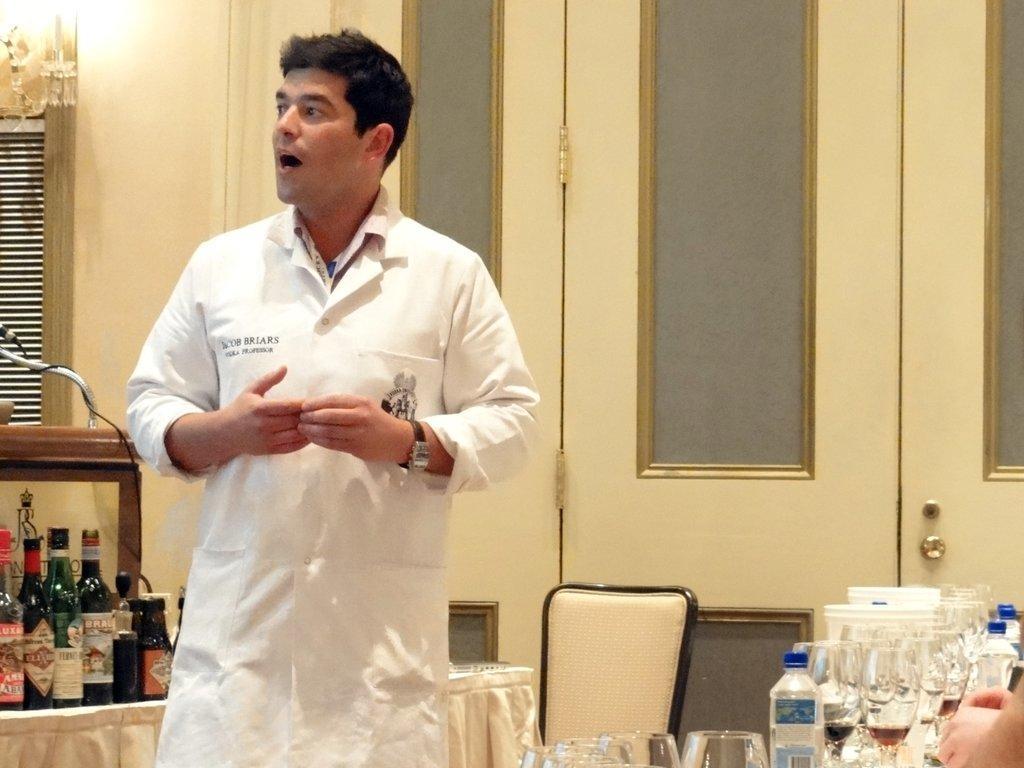Can you describe this image briefly? In this image there is a person wearing a white shirt is standing before a table having few bottles on it. Bottom of image there are few glasses and bottles. Behind it there is a chair. Right bottom there are few persons hand visible. Background there are few windows to the wall. 